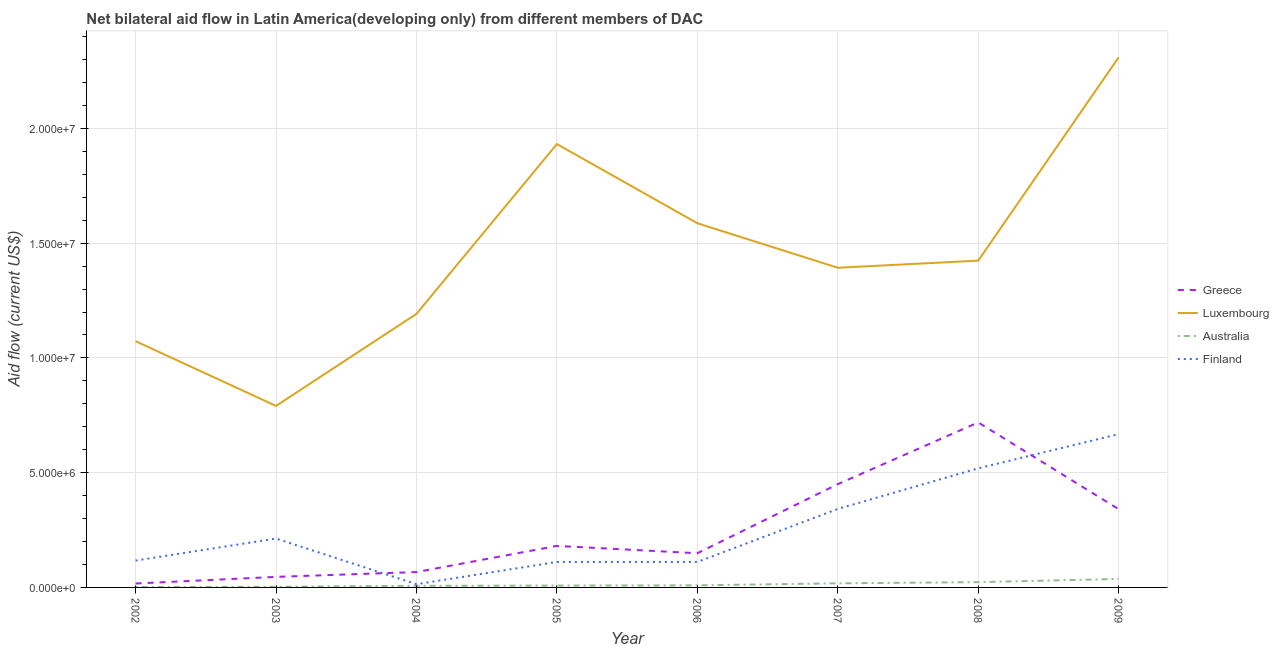How many different coloured lines are there?
Provide a succinct answer. 4. Is the number of lines equal to the number of legend labels?
Offer a terse response. Yes. What is the amount of aid given by australia in 2006?
Your answer should be very brief. 9.00e+04. Across all years, what is the maximum amount of aid given by luxembourg?
Keep it short and to the point. 2.31e+07. Across all years, what is the minimum amount of aid given by australia?
Give a very brief answer. 2.00e+04. What is the total amount of aid given by finland in the graph?
Give a very brief answer. 2.10e+07. What is the difference between the amount of aid given by luxembourg in 2002 and that in 2009?
Make the answer very short. -1.24e+07. What is the difference between the amount of aid given by greece in 2002 and the amount of aid given by finland in 2006?
Ensure brevity in your answer.  -9.40e+05. What is the average amount of aid given by greece per year?
Provide a succinct answer. 2.46e+06. In the year 2003, what is the difference between the amount of aid given by luxembourg and amount of aid given by greece?
Offer a very short reply. 7.45e+06. What is the ratio of the amount of aid given by finland in 2003 to that in 2009?
Keep it short and to the point. 0.32. Is the amount of aid given by finland in 2005 less than that in 2007?
Keep it short and to the point. Yes. Is the difference between the amount of aid given by greece in 2005 and 2007 greater than the difference between the amount of aid given by luxembourg in 2005 and 2007?
Offer a terse response. No. What is the difference between the highest and the second highest amount of aid given by greece?
Provide a succinct answer. 2.69e+06. What is the difference between the highest and the lowest amount of aid given by greece?
Offer a very short reply. 7.02e+06. Is it the case that in every year, the sum of the amount of aid given by greece and amount of aid given by luxembourg is greater than the amount of aid given by australia?
Give a very brief answer. Yes. Is the amount of aid given by australia strictly less than the amount of aid given by luxembourg over the years?
Your answer should be very brief. Yes. What is the difference between two consecutive major ticks on the Y-axis?
Ensure brevity in your answer.  5.00e+06. Does the graph contain grids?
Ensure brevity in your answer.  Yes. Where does the legend appear in the graph?
Your answer should be compact. Center right. What is the title of the graph?
Make the answer very short. Net bilateral aid flow in Latin America(developing only) from different members of DAC. What is the label or title of the X-axis?
Your answer should be compact. Year. What is the Aid flow (current US$) in Luxembourg in 2002?
Your response must be concise. 1.07e+07. What is the Aid flow (current US$) of Australia in 2002?
Offer a terse response. 2.00e+04. What is the Aid flow (current US$) of Finland in 2002?
Your response must be concise. 1.17e+06. What is the Aid flow (current US$) of Luxembourg in 2003?
Give a very brief answer. 7.91e+06. What is the Aid flow (current US$) in Finland in 2003?
Your answer should be very brief. 2.13e+06. What is the Aid flow (current US$) of Greece in 2004?
Your answer should be compact. 6.70e+05. What is the Aid flow (current US$) of Luxembourg in 2004?
Give a very brief answer. 1.19e+07. What is the Aid flow (current US$) in Greece in 2005?
Provide a short and direct response. 1.81e+06. What is the Aid flow (current US$) in Luxembourg in 2005?
Offer a terse response. 1.93e+07. What is the Aid flow (current US$) in Australia in 2005?
Offer a very short reply. 8.00e+04. What is the Aid flow (current US$) in Finland in 2005?
Give a very brief answer. 1.11e+06. What is the Aid flow (current US$) of Greece in 2006?
Offer a very short reply. 1.49e+06. What is the Aid flow (current US$) of Luxembourg in 2006?
Provide a succinct answer. 1.59e+07. What is the Aid flow (current US$) of Finland in 2006?
Ensure brevity in your answer.  1.11e+06. What is the Aid flow (current US$) of Greece in 2007?
Give a very brief answer. 4.50e+06. What is the Aid flow (current US$) of Luxembourg in 2007?
Keep it short and to the point. 1.39e+07. What is the Aid flow (current US$) in Australia in 2007?
Your answer should be very brief. 1.80e+05. What is the Aid flow (current US$) of Finland in 2007?
Your response must be concise. 3.42e+06. What is the Aid flow (current US$) of Greece in 2008?
Provide a succinct answer. 7.19e+06. What is the Aid flow (current US$) of Luxembourg in 2008?
Your response must be concise. 1.42e+07. What is the Aid flow (current US$) of Finland in 2008?
Your answer should be very brief. 5.19e+06. What is the Aid flow (current US$) in Greece in 2009?
Your answer should be compact. 3.41e+06. What is the Aid flow (current US$) of Luxembourg in 2009?
Ensure brevity in your answer.  2.31e+07. What is the Aid flow (current US$) of Finland in 2009?
Offer a very short reply. 6.68e+06. Across all years, what is the maximum Aid flow (current US$) in Greece?
Your answer should be compact. 7.19e+06. Across all years, what is the maximum Aid flow (current US$) in Luxembourg?
Offer a very short reply. 2.31e+07. Across all years, what is the maximum Aid flow (current US$) in Finland?
Your answer should be compact. 6.68e+06. Across all years, what is the minimum Aid flow (current US$) in Luxembourg?
Provide a short and direct response. 7.91e+06. Across all years, what is the minimum Aid flow (current US$) in Australia?
Offer a very short reply. 2.00e+04. What is the total Aid flow (current US$) in Greece in the graph?
Give a very brief answer. 1.97e+07. What is the total Aid flow (current US$) in Luxembourg in the graph?
Offer a very short reply. 1.17e+08. What is the total Aid flow (current US$) in Australia in the graph?
Make the answer very short. 1.07e+06. What is the total Aid flow (current US$) in Finland in the graph?
Your answer should be very brief. 2.10e+07. What is the difference between the Aid flow (current US$) of Luxembourg in 2002 and that in 2003?
Offer a very short reply. 2.82e+06. What is the difference between the Aid flow (current US$) of Finland in 2002 and that in 2003?
Ensure brevity in your answer.  -9.60e+05. What is the difference between the Aid flow (current US$) in Greece in 2002 and that in 2004?
Your answer should be very brief. -5.00e+05. What is the difference between the Aid flow (current US$) in Luxembourg in 2002 and that in 2004?
Offer a very short reply. -1.19e+06. What is the difference between the Aid flow (current US$) in Finland in 2002 and that in 2004?
Your response must be concise. 1.03e+06. What is the difference between the Aid flow (current US$) of Greece in 2002 and that in 2005?
Provide a succinct answer. -1.64e+06. What is the difference between the Aid flow (current US$) of Luxembourg in 2002 and that in 2005?
Ensure brevity in your answer.  -8.59e+06. What is the difference between the Aid flow (current US$) in Australia in 2002 and that in 2005?
Offer a terse response. -6.00e+04. What is the difference between the Aid flow (current US$) of Greece in 2002 and that in 2006?
Your answer should be compact. -1.32e+06. What is the difference between the Aid flow (current US$) in Luxembourg in 2002 and that in 2006?
Make the answer very short. -5.14e+06. What is the difference between the Aid flow (current US$) of Australia in 2002 and that in 2006?
Provide a succinct answer. -7.00e+04. What is the difference between the Aid flow (current US$) in Greece in 2002 and that in 2007?
Keep it short and to the point. -4.33e+06. What is the difference between the Aid flow (current US$) of Luxembourg in 2002 and that in 2007?
Your answer should be very brief. -3.20e+06. What is the difference between the Aid flow (current US$) in Australia in 2002 and that in 2007?
Provide a short and direct response. -1.60e+05. What is the difference between the Aid flow (current US$) of Finland in 2002 and that in 2007?
Offer a very short reply. -2.25e+06. What is the difference between the Aid flow (current US$) of Greece in 2002 and that in 2008?
Offer a terse response. -7.02e+06. What is the difference between the Aid flow (current US$) of Luxembourg in 2002 and that in 2008?
Your answer should be compact. -3.51e+06. What is the difference between the Aid flow (current US$) of Finland in 2002 and that in 2008?
Give a very brief answer. -4.02e+06. What is the difference between the Aid flow (current US$) of Greece in 2002 and that in 2009?
Offer a very short reply. -3.24e+06. What is the difference between the Aid flow (current US$) of Luxembourg in 2002 and that in 2009?
Offer a terse response. -1.24e+07. What is the difference between the Aid flow (current US$) of Australia in 2002 and that in 2009?
Your response must be concise. -3.50e+05. What is the difference between the Aid flow (current US$) in Finland in 2002 and that in 2009?
Your response must be concise. -5.51e+06. What is the difference between the Aid flow (current US$) in Luxembourg in 2003 and that in 2004?
Keep it short and to the point. -4.01e+06. What is the difference between the Aid flow (current US$) of Finland in 2003 and that in 2004?
Give a very brief answer. 1.99e+06. What is the difference between the Aid flow (current US$) in Greece in 2003 and that in 2005?
Give a very brief answer. -1.35e+06. What is the difference between the Aid flow (current US$) in Luxembourg in 2003 and that in 2005?
Your answer should be compact. -1.14e+07. What is the difference between the Aid flow (current US$) in Finland in 2003 and that in 2005?
Make the answer very short. 1.02e+06. What is the difference between the Aid flow (current US$) in Greece in 2003 and that in 2006?
Your answer should be compact. -1.03e+06. What is the difference between the Aid flow (current US$) of Luxembourg in 2003 and that in 2006?
Provide a short and direct response. -7.96e+06. What is the difference between the Aid flow (current US$) of Australia in 2003 and that in 2006?
Ensure brevity in your answer.  -6.00e+04. What is the difference between the Aid flow (current US$) in Finland in 2003 and that in 2006?
Ensure brevity in your answer.  1.02e+06. What is the difference between the Aid flow (current US$) in Greece in 2003 and that in 2007?
Give a very brief answer. -4.04e+06. What is the difference between the Aid flow (current US$) of Luxembourg in 2003 and that in 2007?
Provide a succinct answer. -6.02e+06. What is the difference between the Aid flow (current US$) of Finland in 2003 and that in 2007?
Ensure brevity in your answer.  -1.29e+06. What is the difference between the Aid flow (current US$) in Greece in 2003 and that in 2008?
Your answer should be very brief. -6.73e+06. What is the difference between the Aid flow (current US$) of Luxembourg in 2003 and that in 2008?
Your answer should be very brief. -6.33e+06. What is the difference between the Aid flow (current US$) of Australia in 2003 and that in 2008?
Provide a succinct answer. -2.00e+05. What is the difference between the Aid flow (current US$) in Finland in 2003 and that in 2008?
Ensure brevity in your answer.  -3.06e+06. What is the difference between the Aid flow (current US$) in Greece in 2003 and that in 2009?
Your response must be concise. -2.95e+06. What is the difference between the Aid flow (current US$) in Luxembourg in 2003 and that in 2009?
Your response must be concise. -1.52e+07. What is the difference between the Aid flow (current US$) of Australia in 2003 and that in 2009?
Make the answer very short. -3.40e+05. What is the difference between the Aid flow (current US$) of Finland in 2003 and that in 2009?
Keep it short and to the point. -4.55e+06. What is the difference between the Aid flow (current US$) in Greece in 2004 and that in 2005?
Offer a very short reply. -1.14e+06. What is the difference between the Aid flow (current US$) in Luxembourg in 2004 and that in 2005?
Your response must be concise. -7.40e+06. What is the difference between the Aid flow (current US$) in Australia in 2004 and that in 2005?
Ensure brevity in your answer.  -10000. What is the difference between the Aid flow (current US$) of Finland in 2004 and that in 2005?
Make the answer very short. -9.70e+05. What is the difference between the Aid flow (current US$) of Greece in 2004 and that in 2006?
Provide a succinct answer. -8.20e+05. What is the difference between the Aid flow (current US$) of Luxembourg in 2004 and that in 2006?
Keep it short and to the point. -3.95e+06. What is the difference between the Aid flow (current US$) in Finland in 2004 and that in 2006?
Give a very brief answer. -9.70e+05. What is the difference between the Aid flow (current US$) of Greece in 2004 and that in 2007?
Your answer should be very brief. -3.83e+06. What is the difference between the Aid flow (current US$) of Luxembourg in 2004 and that in 2007?
Provide a short and direct response. -2.01e+06. What is the difference between the Aid flow (current US$) of Finland in 2004 and that in 2007?
Ensure brevity in your answer.  -3.28e+06. What is the difference between the Aid flow (current US$) of Greece in 2004 and that in 2008?
Offer a terse response. -6.52e+06. What is the difference between the Aid flow (current US$) in Luxembourg in 2004 and that in 2008?
Your response must be concise. -2.32e+06. What is the difference between the Aid flow (current US$) in Finland in 2004 and that in 2008?
Offer a very short reply. -5.05e+06. What is the difference between the Aid flow (current US$) of Greece in 2004 and that in 2009?
Make the answer very short. -2.74e+06. What is the difference between the Aid flow (current US$) of Luxembourg in 2004 and that in 2009?
Ensure brevity in your answer.  -1.12e+07. What is the difference between the Aid flow (current US$) in Finland in 2004 and that in 2009?
Your answer should be compact. -6.54e+06. What is the difference between the Aid flow (current US$) in Greece in 2005 and that in 2006?
Give a very brief answer. 3.20e+05. What is the difference between the Aid flow (current US$) in Luxembourg in 2005 and that in 2006?
Give a very brief answer. 3.45e+06. What is the difference between the Aid flow (current US$) of Australia in 2005 and that in 2006?
Your answer should be very brief. -10000. What is the difference between the Aid flow (current US$) of Greece in 2005 and that in 2007?
Give a very brief answer. -2.69e+06. What is the difference between the Aid flow (current US$) of Luxembourg in 2005 and that in 2007?
Provide a short and direct response. 5.39e+06. What is the difference between the Aid flow (current US$) of Australia in 2005 and that in 2007?
Offer a very short reply. -1.00e+05. What is the difference between the Aid flow (current US$) of Finland in 2005 and that in 2007?
Give a very brief answer. -2.31e+06. What is the difference between the Aid flow (current US$) in Greece in 2005 and that in 2008?
Your response must be concise. -5.38e+06. What is the difference between the Aid flow (current US$) in Luxembourg in 2005 and that in 2008?
Your answer should be very brief. 5.08e+06. What is the difference between the Aid flow (current US$) in Australia in 2005 and that in 2008?
Your answer should be compact. -1.50e+05. What is the difference between the Aid flow (current US$) of Finland in 2005 and that in 2008?
Keep it short and to the point. -4.08e+06. What is the difference between the Aid flow (current US$) in Greece in 2005 and that in 2009?
Your response must be concise. -1.60e+06. What is the difference between the Aid flow (current US$) in Luxembourg in 2005 and that in 2009?
Your answer should be very brief. -3.78e+06. What is the difference between the Aid flow (current US$) of Finland in 2005 and that in 2009?
Provide a succinct answer. -5.57e+06. What is the difference between the Aid flow (current US$) in Greece in 2006 and that in 2007?
Make the answer very short. -3.01e+06. What is the difference between the Aid flow (current US$) in Luxembourg in 2006 and that in 2007?
Give a very brief answer. 1.94e+06. What is the difference between the Aid flow (current US$) of Finland in 2006 and that in 2007?
Your response must be concise. -2.31e+06. What is the difference between the Aid flow (current US$) of Greece in 2006 and that in 2008?
Keep it short and to the point. -5.70e+06. What is the difference between the Aid flow (current US$) of Luxembourg in 2006 and that in 2008?
Give a very brief answer. 1.63e+06. What is the difference between the Aid flow (current US$) in Finland in 2006 and that in 2008?
Make the answer very short. -4.08e+06. What is the difference between the Aid flow (current US$) in Greece in 2006 and that in 2009?
Your response must be concise. -1.92e+06. What is the difference between the Aid flow (current US$) in Luxembourg in 2006 and that in 2009?
Make the answer very short. -7.23e+06. What is the difference between the Aid flow (current US$) in Australia in 2006 and that in 2009?
Your answer should be very brief. -2.80e+05. What is the difference between the Aid flow (current US$) of Finland in 2006 and that in 2009?
Your response must be concise. -5.57e+06. What is the difference between the Aid flow (current US$) of Greece in 2007 and that in 2008?
Provide a succinct answer. -2.69e+06. What is the difference between the Aid flow (current US$) in Luxembourg in 2007 and that in 2008?
Keep it short and to the point. -3.10e+05. What is the difference between the Aid flow (current US$) of Australia in 2007 and that in 2008?
Ensure brevity in your answer.  -5.00e+04. What is the difference between the Aid flow (current US$) of Finland in 2007 and that in 2008?
Offer a very short reply. -1.77e+06. What is the difference between the Aid flow (current US$) of Greece in 2007 and that in 2009?
Provide a short and direct response. 1.09e+06. What is the difference between the Aid flow (current US$) in Luxembourg in 2007 and that in 2009?
Your answer should be compact. -9.17e+06. What is the difference between the Aid flow (current US$) in Finland in 2007 and that in 2009?
Make the answer very short. -3.26e+06. What is the difference between the Aid flow (current US$) of Greece in 2008 and that in 2009?
Your answer should be compact. 3.78e+06. What is the difference between the Aid flow (current US$) of Luxembourg in 2008 and that in 2009?
Your answer should be very brief. -8.86e+06. What is the difference between the Aid flow (current US$) of Australia in 2008 and that in 2009?
Provide a short and direct response. -1.40e+05. What is the difference between the Aid flow (current US$) in Finland in 2008 and that in 2009?
Your answer should be compact. -1.49e+06. What is the difference between the Aid flow (current US$) of Greece in 2002 and the Aid flow (current US$) of Luxembourg in 2003?
Ensure brevity in your answer.  -7.74e+06. What is the difference between the Aid flow (current US$) in Greece in 2002 and the Aid flow (current US$) in Finland in 2003?
Keep it short and to the point. -1.96e+06. What is the difference between the Aid flow (current US$) of Luxembourg in 2002 and the Aid flow (current US$) of Australia in 2003?
Keep it short and to the point. 1.07e+07. What is the difference between the Aid flow (current US$) in Luxembourg in 2002 and the Aid flow (current US$) in Finland in 2003?
Make the answer very short. 8.60e+06. What is the difference between the Aid flow (current US$) of Australia in 2002 and the Aid flow (current US$) of Finland in 2003?
Your response must be concise. -2.11e+06. What is the difference between the Aid flow (current US$) of Greece in 2002 and the Aid flow (current US$) of Luxembourg in 2004?
Offer a very short reply. -1.18e+07. What is the difference between the Aid flow (current US$) of Luxembourg in 2002 and the Aid flow (current US$) of Australia in 2004?
Give a very brief answer. 1.07e+07. What is the difference between the Aid flow (current US$) in Luxembourg in 2002 and the Aid flow (current US$) in Finland in 2004?
Ensure brevity in your answer.  1.06e+07. What is the difference between the Aid flow (current US$) in Australia in 2002 and the Aid flow (current US$) in Finland in 2004?
Provide a succinct answer. -1.20e+05. What is the difference between the Aid flow (current US$) in Greece in 2002 and the Aid flow (current US$) in Luxembourg in 2005?
Offer a very short reply. -1.92e+07. What is the difference between the Aid flow (current US$) of Greece in 2002 and the Aid flow (current US$) of Finland in 2005?
Provide a succinct answer. -9.40e+05. What is the difference between the Aid flow (current US$) of Luxembourg in 2002 and the Aid flow (current US$) of Australia in 2005?
Make the answer very short. 1.06e+07. What is the difference between the Aid flow (current US$) of Luxembourg in 2002 and the Aid flow (current US$) of Finland in 2005?
Offer a very short reply. 9.62e+06. What is the difference between the Aid flow (current US$) in Australia in 2002 and the Aid flow (current US$) in Finland in 2005?
Provide a succinct answer. -1.09e+06. What is the difference between the Aid flow (current US$) of Greece in 2002 and the Aid flow (current US$) of Luxembourg in 2006?
Keep it short and to the point. -1.57e+07. What is the difference between the Aid flow (current US$) in Greece in 2002 and the Aid flow (current US$) in Australia in 2006?
Your answer should be very brief. 8.00e+04. What is the difference between the Aid flow (current US$) in Greece in 2002 and the Aid flow (current US$) in Finland in 2006?
Your answer should be compact. -9.40e+05. What is the difference between the Aid flow (current US$) in Luxembourg in 2002 and the Aid flow (current US$) in Australia in 2006?
Provide a succinct answer. 1.06e+07. What is the difference between the Aid flow (current US$) of Luxembourg in 2002 and the Aid flow (current US$) of Finland in 2006?
Offer a very short reply. 9.62e+06. What is the difference between the Aid flow (current US$) of Australia in 2002 and the Aid flow (current US$) of Finland in 2006?
Provide a succinct answer. -1.09e+06. What is the difference between the Aid flow (current US$) in Greece in 2002 and the Aid flow (current US$) in Luxembourg in 2007?
Make the answer very short. -1.38e+07. What is the difference between the Aid flow (current US$) of Greece in 2002 and the Aid flow (current US$) of Australia in 2007?
Keep it short and to the point. -10000. What is the difference between the Aid flow (current US$) in Greece in 2002 and the Aid flow (current US$) in Finland in 2007?
Give a very brief answer. -3.25e+06. What is the difference between the Aid flow (current US$) in Luxembourg in 2002 and the Aid flow (current US$) in Australia in 2007?
Provide a short and direct response. 1.06e+07. What is the difference between the Aid flow (current US$) in Luxembourg in 2002 and the Aid flow (current US$) in Finland in 2007?
Ensure brevity in your answer.  7.31e+06. What is the difference between the Aid flow (current US$) of Australia in 2002 and the Aid flow (current US$) of Finland in 2007?
Make the answer very short. -3.40e+06. What is the difference between the Aid flow (current US$) of Greece in 2002 and the Aid flow (current US$) of Luxembourg in 2008?
Your answer should be compact. -1.41e+07. What is the difference between the Aid flow (current US$) of Greece in 2002 and the Aid flow (current US$) of Australia in 2008?
Make the answer very short. -6.00e+04. What is the difference between the Aid flow (current US$) in Greece in 2002 and the Aid flow (current US$) in Finland in 2008?
Your response must be concise. -5.02e+06. What is the difference between the Aid flow (current US$) in Luxembourg in 2002 and the Aid flow (current US$) in Australia in 2008?
Your response must be concise. 1.05e+07. What is the difference between the Aid flow (current US$) of Luxembourg in 2002 and the Aid flow (current US$) of Finland in 2008?
Provide a succinct answer. 5.54e+06. What is the difference between the Aid flow (current US$) in Australia in 2002 and the Aid flow (current US$) in Finland in 2008?
Ensure brevity in your answer.  -5.17e+06. What is the difference between the Aid flow (current US$) in Greece in 2002 and the Aid flow (current US$) in Luxembourg in 2009?
Provide a short and direct response. -2.29e+07. What is the difference between the Aid flow (current US$) in Greece in 2002 and the Aid flow (current US$) in Finland in 2009?
Your answer should be compact. -6.51e+06. What is the difference between the Aid flow (current US$) in Luxembourg in 2002 and the Aid flow (current US$) in Australia in 2009?
Give a very brief answer. 1.04e+07. What is the difference between the Aid flow (current US$) in Luxembourg in 2002 and the Aid flow (current US$) in Finland in 2009?
Give a very brief answer. 4.05e+06. What is the difference between the Aid flow (current US$) of Australia in 2002 and the Aid flow (current US$) of Finland in 2009?
Your answer should be very brief. -6.66e+06. What is the difference between the Aid flow (current US$) in Greece in 2003 and the Aid flow (current US$) in Luxembourg in 2004?
Your response must be concise. -1.15e+07. What is the difference between the Aid flow (current US$) of Greece in 2003 and the Aid flow (current US$) of Finland in 2004?
Ensure brevity in your answer.  3.20e+05. What is the difference between the Aid flow (current US$) in Luxembourg in 2003 and the Aid flow (current US$) in Australia in 2004?
Provide a succinct answer. 7.84e+06. What is the difference between the Aid flow (current US$) of Luxembourg in 2003 and the Aid flow (current US$) of Finland in 2004?
Your answer should be compact. 7.77e+06. What is the difference between the Aid flow (current US$) of Greece in 2003 and the Aid flow (current US$) of Luxembourg in 2005?
Your answer should be very brief. -1.89e+07. What is the difference between the Aid flow (current US$) of Greece in 2003 and the Aid flow (current US$) of Australia in 2005?
Offer a terse response. 3.80e+05. What is the difference between the Aid flow (current US$) in Greece in 2003 and the Aid flow (current US$) in Finland in 2005?
Keep it short and to the point. -6.50e+05. What is the difference between the Aid flow (current US$) of Luxembourg in 2003 and the Aid flow (current US$) of Australia in 2005?
Give a very brief answer. 7.83e+06. What is the difference between the Aid flow (current US$) of Luxembourg in 2003 and the Aid flow (current US$) of Finland in 2005?
Give a very brief answer. 6.80e+06. What is the difference between the Aid flow (current US$) of Australia in 2003 and the Aid flow (current US$) of Finland in 2005?
Keep it short and to the point. -1.08e+06. What is the difference between the Aid flow (current US$) of Greece in 2003 and the Aid flow (current US$) of Luxembourg in 2006?
Provide a short and direct response. -1.54e+07. What is the difference between the Aid flow (current US$) of Greece in 2003 and the Aid flow (current US$) of Finland in 2006?
Ensure brevity in your answer.  -6.50e+05. What is the difference between the Aid flow (current US$) of Luxembourg in 2003 and the Aid flow (current US$) of Australia in 2006?
Offer a very short reply. 7.82e+06. What is the difference between the Aid flow (current US$) of Luxembourg in 2003 and the Aid flow (current US$) of Finland in 2006?
Offer a terse response. 6.80e+06. What is the difference between the Aid flow (current US$) in Australia in 2003 and the Aid flow (current US$) in Finland in 2006?
Your response must be concise. -1.08e+06. What is the difference between the Aid flow (current US$) in Greece in 2003 and the Aid flow (current US$) in Luxembourg in 2007?
Your answer should be compact. -1.35e+07. What is the difference between the Aid flow (current US$) of Greece in 2003 and the Aid flow (current US$) of Finland in 2007?
Keep it short and to the point. -2.96e+06. What is the difference between the Aid flow (current US$) in Luxembourg in 2003 and the Aid flow (current US$) in Australia in 2007?
Provide a short and direct response. 7.73e+06. What is the difference between the Aid flow (current US$) of Luxembourg in 2003 and the Aid flow (current US$) of Finland in 2007?
Offer a very short reply. 4.49e+06. What is the difference between the Aid flow (current US$) of Australia in 2003 and the Aid flow (current US$) of Finland in 2007?
Offer a terse response. -3.39e+06. What is the difference between the Aid flow (current US$) in Greece in 2003 and the Aid flow (current US$) in Luxembourg in 2008?
Make the answer very short. -1.38e+07. What is the difference between the Aid flow (current US$) in Greece in 2003 and the Aid flow (current US$) in Australia in 2008?
Ensure brevity in your answer.  2.30e+05. What is the difference between the Aid flow (current US$) in Greece in 2003 and the Aid flow (current US$) in Finland in 2008?
Make the answer very short. -4.73e+06. What is the difference between the Aid flow (current US$) in Luxembourg in 2003 and the Aid flow (current US$) in Australia in 2008?
Make the answer very short. 7.68e+06. What is the difference between the Aid flow (current US$) in Luxembourg in 2003 and the Aid flow (current US$) in Finland in 2008?
Your answer should be very brief. 2.72e+06. What is the difference between the Aid flow (current US$) in Australia in 2003 and the Aid flow (current US$) in Finland in 2008?
Provide a succinct answer. -5.16e+06. What is the difference between the Aid flow (current US$) of Greece in 2003 and the Aid flow (current US$) of Luxembourg in 2009?
Provide a short and direct response. -2.26e+07. What is the difference between the Aid flow (current US$) of Greece in 2003 and the Aid flow (current US$) of Australia in 2009?
Your answer should be very brief. 9.00e+04. What is the difference between the Aid flow (current US$) of Greece in 2003 and the Aid flow (current US$) of Finland in 2009?
Keep it short and to the point. -6.22e+06. What is the difference between the Aid flow (current US$) in Luxembourg in 2003 and the Aid flow (current US$) in Australia in 2009?
Ensure brevity in your answer.  7.54e+06. What is the difference between the Aid flow (current US$) in Luxembourg in 2003 and the Aid flow (current US$) in Finland in 2009?
Your answer should be very brief. 1.23e+06. What is the difference between the Aid flow (current US$) in Australia in 2003 and the Aid flow (current US$) in Finland in 2009?
Keep it short and to the point. -6.65e+06. What is the difference between the Aid flow (current US$) in Greece in 2004 and the Aid flow (current US$) in Luxembourg in 2005?
Provide a succinct answer. -1.86e+07. What is the difference between the Aid flow (current US$) of Greece in 2004 and the Aid flow (current US$) of Australia in 2005?
Offer a terse response. 5.90e+05. What is the difference between the Aid flow (current US$) of Greece in 2004 and the Aid flow (current US$) of Finland in 2005?
Ensure brevity in your answer.  -4.40e+05. What is the difference between the Aid flow (current US$) of Luxembourg in 2004 and the Aid flow (current US$) of Australia in 2005?
Your answer should be very brief. 1.18e+07. What is the difference between the Aid flow (current US$) of Luxembourg in 2004 and the Aid flow (current US$) of Finland in 2005?
Keep it short and to the point. 1.08e+07. What is the difference between the Aid flow (current US$) of Australia in 2004 and the Aid flow (current US$) of Finland in 2005?
Your answer should be very brief. -1.04e+06. What is the difference between the Aid flow (current US$) of Greece in 2004 and the Aid flow (current US$) of Luxembourg in 2006?
Provide a succinct answer. -1.52e+07. What is the difference between the Aid flow (current US$) in Greece in 2004 and the Aid flow (current US$) in Australia in 2006?
Ensure brevity in your answer.  5.80e+05. What is the difference between the Aid flow (current US$) in Greece in 2004 and the Aid flow (current US$) in Finland in 2006?
Make the answer very short. -4.40e+05. What is the difference between the Aid flow (current US$) in Luxembourg in 2004 and the Aid flow (current US$) in Australia in 2006?
Ensure brevity in your answer.  1.18e+07. What is the difference between the Aid flow (current US$) of Luxembourg in 2004 and the Aid flow (current US$) of Finland in 2006?
Your answer should be very brief. 1.08e+07. What is the difference between the Aid flow (current US$) in Australia in 2004 and the Aid flow (current US$) in Finland in 2006?
Your answer should be compact. -1.04e+06. What is the difference between the Aid flow (current US$) in Greece in 2004 and the Aid flow (current US$) in Luxembourg in 2007?
Your response must be concise. -1.33e+07. What is the difference between the Aid flow (current US$) in Greece in 2004 and the Aid flow (current US$) in Australia in 2007?
Keep it short and to the point. 4.90e+05. What is the difference between the Aid flow (current US$) in Greece in 2004 and the Aid flow (current US$) in Finland in 2007?
Provide a short and direct response. -2.75e+06. What is the difference between the Aid flow (current US$) in Luxembourg in 2004 and the Aid flow (current US$) in Australia in 2007?
Your answer should be very brief. 1.17e+07. What is the difference between the Aid flow (current US$) of Luxembourg in 2004 and the Aid flow (current US$) of Finland in 2007?
Your answer should be very brief. 8.50e+06. What is the difference between the Aid flow (current US$) of Australia in 2004 and the Aid flow (current US$) of Finland in 2007?
Offer a very short reply. -3.35e+06. What is the difference between the Aid flow (current US$) in Greece in 2004 and the Aid flow (current US$) in Luxembourg in 2008?
Offer a very short reply. -1.36e+07. What is the difference between the Aid flow (current US$) in Greece in 2004 and the Aid flow (current US$) in Australia in 2008?
Offer a very short reply. 4.40e+05. What is the difference between the Aid flow (current US$) of Greece in 2004 and the Aid flow (current US$) of Finland in 2008?
Give a very brief answer. -4.52e+06. What is the difference between the Aid flow (current US$) of Luxembourg in 2004 and the Aid flow (current US$) of Australia in 2008?
Make the answer very short. 1.17e+07. What is the difference between the Aid flow (current US$) of Luxembourg in 2004 and the Aid flow (current US$) of Finland in 2008?
Make the answer very short. 6.73e+06. What is the difference between the Aid flow (current US$) of Australia in 2004 and the Aid flow (current US$) of Finland in 2008?
Keep it short and to the point. -5.12e+06. What is the difference between the Aid flow (current US$) in Greece in 2004 and the Aid flow (current US$) in Luxembourg in 2009?
Ensure brevity in your answer.  -2.24e+07. What is the difference between the Aid flow (current US$) in Greece in 2004 and the Aid flow (current US$) in Finland in 2009?
Offer a terse response. -6.01e+06. What is the difference between the Aid flow (current US$) of Luxembourg in 2004 and the Aid flow (current US$) of Australia in 2009?
Ensure brevity in your answer.  1.16e+07. What is the difference between the Aid flow (current US$) of Luxembourg in 2004 and the Aid flow (current US$) of Finland in 2009?
Give a very brief answer. 5.24e+06. What is the difference between the Aid flow (current US$) of Australia in 2004 and the Aid flow (current US$) of Finland in 2009?
Give a very brief answer. -6.61e+06. What is the difference between the Aid flow (current US$) of Greece in 2005 and the Aid flow (current US$) of Luxembourg in 2006?
Give a very brief answer. -1.41e+07. What is the difference between the Aid flow (current US$) of Greece in 2005 and the Aid flow (current US$) of Australia in 2006?
Provide a succinct answer. 1.72e+06. What is the difference between the Aid flow (current US$) in Greece in 2005 and the Aid flow (current US$) in Finland in 2006?
Give a very brief answer. 7.00e+05. What is the difference between the Aid flow (current US$) of Luxembourg in 2005 and the Aid flow (current US$) of Australia in 2006?
Your answer should be compact. 1.92e+07. What is the difference between the Aid flow (current US$) in Luxembourg in 2005 and the Aid flow (current US$) in Finland in 2006?
Make the answer very short. 1.82e+07. What is the difference between the Aid flow (current US$) in Australia in 2005 and the Aid flow (current US$) in Finland in 2006?
Provide a succinct answer. -1.03e+06. What is the difference between the Aid flow (current US$) in Greece in 2005 and the Aid flow (current US$) in Luxembourg in 2007?
Ensure brevity in your answer.  -1.21e+07. What is the difference between the Aid flow (current US$) of Greece in 2005 and the Aid flow (current US$) of Australia in 2007?
Ensure brevity in your answer.  1.63e+06. What is the difference between the Aid flow (current US$) in Greece in 2005 and the Aid flow (current US$) in Finland in 2007?
Provide a succinct answer. -1.61e+06. What is the difference between the Aid flow (current US$) in Luxembourg in 2005 and the Aid flow (current US$) in Australia in 2007?
Provide a succinct answer. 1.91e+07. What is the difference between the Aid flow (current US$) of Luxembourg in 2005 and the Aid flow (current US$) of Finland in 2007?
Provide a succinct answer. 1.59e+07. What is the difference between the Aid flow (current US$) of Australia in 2005 and the Aid flow (current US$) of Finland in 2007?
Provide a succinct answer. -3.34e+06. What is the difference between the Aid flow (current US$) of Greece in 2005 and the Aid flow (current US$) of Luxembourg in 2008?
Keep it short and to the point. -1.24e+07. What is the difference between the Aid flow (current US$) in Greece in 2005 and the Aid flow (current US$) in Australia in 2008?
Your response must be concise. 1.58e+06. What is the difference between the Aid flow (current US$) in Greece in 2005 and the Aid flow (current US$) in Finland in 2008?
Give a very brief answer. -3.38e+06. What is the difference between the Aid flow (current US$) in Luxembourg in 2005 and the Aid flow (current US$) in Australia in 2008?
Keep it short and to the point. 1.91e+07. What is the difference between the Aid flow (current US$) in Luxembourg in 2005 and the Aid flow (current US$) in Finland in 2008?
Provide a succinct answer. 1.41e+07. What is the difference between the Aid flow (current US$) in Australia in 2005 and the Aid flow (current US$) in Finland in 2008?
Your response must be concise. -5.11e+06. What is the difference between the Aid flow (current US$) of Greece in 2005 and the Aid flow (current US$) of Luxembourg in 2009?
Give a very brief answer. -2.13e+07. What is the difference between the Aid flow (current US$) of Greece in 2005 and the Aid flow (current US$) of Australia in 2009?
Your response must be concise. 1.44e+06. What is the difference between the Aid flow (current US$) of Greece in 2005 and the Aid flow (current US$) of Finland in 2009?
Keep it short and to the point. -4.87e+06. What is the difference between the Aid flow (current US$) in Luxembourg in 2005 and the Aid flow (current US$) in Australia in 2009?
Give a very brief answer. 1.90e+07. What is the difference between the Aid flow (current US$) in Luxembourg in 2005 and the Aid flow (current US$) in Finland in 2009?
Provide a short and direct response. 1.26e+07. What is the difference between the Aid flow (current US$) in Australia in 2005 and the Aid flow (current US$) in Finland in 2009?
Offer a terse response. -6.60e+06. What is the difference between the Aid flow (current US$) in Greece in 2006 and the Aid flow (current US$) in Luxembourg in 2007?
Give a very brief answer. -1.24e+07. What is the difference between the Aid flow (current US$) of Greece in 2006 and the Aid flow (current US$) of Australia in 2007?
Give a very brief answer. 1.31e+06. What is the difference between the Aid flow (current US$) of Greece in 2006 and the Aid flow (current US$) of Finland in 2007?
Your answer should be very brief. -1.93e+06. What is the difference between the Aid flow (current US$) in Luxembourg in 2006 and the Aid flow (current US$) in Australia in 2007?
Provide a short and direct response. 1.57e+07. What is the difference between the Aid flow (current US$) of Luxembourg in 2006 and the Aid flow (current US$) of Finland in 2007?
Offer a terse response. 1.24e+07. What is the difference between the Aid flow (current US$) of Australia in 2006 and the Aid flow (current US$) of Finland in 2007?
Your answer should be very brief. -3.33e+06. What is the difference between the Aid flow (current US$) in Greece in 2006 and the Aid flow (current US$) in Luxembourg in 2008?
Provide a succinct answer. -1.28e+07. What is the difference between the Aid flow (current US$) in Greece in 2006 and the Aid flow (current US$) in Australia in 2008?
Your response must be concise. 1.26e+06. What is the difference between the Aid flow (current US$) in Greece in 2006 and the Aid flow (current US$) in Finland in 2008?
Ensure brevity in your answer.  -3.70e+06. What is the difference between the Aid flow (current US$) of Luxembourg in 2006 and the Aid flow (current US$) of Australia in 2008?
Your answer should be compact. 1.56e+07. What is the difference between the Aid flow (current US$) in Luxembourg in 2006 and the Aid flow (current US$) in Finland in 2008?
Provide a short and direct response. 1.07e+07. What is the difference between the Aid flow (current US$) in Australia in 2006 and the Aid flow (current US$) in Finland in 2008?
Your response must be concise. -5.10e+06. What is the difference between the Aid flow (current US$) of Greece in 2006 and the Aid flow (current US$) of Luxembourg in 2009?
Offer a very short reply. -2.16e+07. What is the difference between the Aid flow (current US$) in Greece in 2006 and the Aid flow (current US$) in Australia in 2009?
Provide a short and direct response. 1.12e+06. What is the difference between the Aid flow (current US$) of Greece in 2006 and the Aid flow (current US$) of Finland in 2009?
Ensure brevity in your answer.  -5.19e+06. What is the difference between the Aid flow (current US$) in Luxembourg in 2006 and the Aid flow (current US$) in Australia in 2009?
Offer a very short reply. 1.55e+07. What is the difference between the Aid flow (current US$) of Luxembourg in 2006 and the Aid flow (current US$) of Finland in 2009?
Ensure brevity in your answer.  9.19e+06. What is the difference between the Aid flow (current US$) in Australia in 2006 and the Aid flow (current US$) in Finland in 2009?
Offer a terse response. -6.59e+06. What is the difference between the Aid flow (current US$) of Greece in 2007 and the Aid flow (current US$) of Luxembourg in 2008?
Give a very brief answer. -9.74e+06. What is the difference between the Aid flow (current US$) in Greece in 2007 and the Aid flow (current US$) in Australia in 2008?
Offer a terse response. 4.27e+06. What is the difference between the Aid flow (current US$) of Greece in 2007 and the Aid flow (current US$) of Finland in 2008?
Your response must be concise. -6.90e+05. What is the difference between the Aid flow (current US$) of Luxembourg in 2007 and the Aid flow (current US$) of Australia in 2008?
Give a very brief answer. 1.37e+07. What is the difference between the Aid flow (current US$) in Luxembourg in 2007 and the Aid flow (current US$) in Finland in 2008?
Keep it short and to the point. 8.74e+06. What is the difference between the Aid flow (current US$) of Australia in 2007 and the Aid flow (current US$) of Finland in 2008?
Your response must be concise. -5.01e+06. What is the difference between the Aid flow (current US$) of Greece in 2007 and the Aid flow (current US$) of Luxembourg in 2009?
Offer a very short reply. -1.86e+07. What is the difference between the Aid flow (current US$) of Greece in 2007 and the Aid flow (current US$) of Australia in 2009?
Your response must be concise. 4.13e+06. What is the difference between the Aid flow (current US$) in Greece in 2007 and the Aid flow (current US$) in Finland in 2009?
Give a very brief answer. -2.18e+06. What is the difference between the Aid flow (current US$) of Luxembourg in 2007 and the Aid flow (current US$) of Australia in 2009?
Keep it short and to the point. 1.36e+07. What is the difference between the Aid flow (current US$) in Luxembourg in 2007 and the Aid flow (current US$) in Finland in 2009?
Your answer should be compact. 7.25e+06. What is the difference between the Aid flow (current US$) of Australia in 2007 and the Aid flow (current US$) of Finland in 2009?
Offer a terse response. -6.50e+06. What is the difference between the Aid flow (current US$) in Greece in 2008 and the Aid flow (current US$) in Luxembourg in 2009?
Provide a succinct answer. -1.59e+07. What is the difference between the Aid flow (current US$) in Greece in 2008 and the Aid flow (current US$) in Australia in 2009?
Offer a terse response. 6.82e+06. What is the difference between the Aid flow (current US$) of Greece in 2008 and the Aid flow (current US$) of Finland in 2009?
Offer a very short reply. 5.10e+05. What is the difference between the Aid flow (current US$) of Luxembourg in 2008 and the Aid flow (current US$) of Australia in 2009?
Give a very brief answer. 1.39e+07. What is the difference between the Aid flow (current US$) of Luxembourg in 2008 and the Aid flow (current US$) of Finland in 2009?
Offer a terse response. 7.56e+06. What is the difference between the Aid flow (current US$) of Australia in 2008 and the Aid flow (current US$) of Finland in 2009?
Keep it short and to the point. -6.45e+06. What is the average Aid flow (current US$) in Greece per year?
Your answer should be very brief. 2.46e+06. What is the average Aid flow (current US$) in Luxembourg per year?
Provide a short and direct response. 1.46e+07. What is the average Aid flow (current US$) of Australia per year?
Give a very brief answer. 1.34e+05. What is the average Aid flow (current US$) in Finland per year?
Your answer should be compact. 2.62e+06. In the year 2002, what is the difference between the Aid flow (current US$) of Greece and Aid flow (current US$) of Luxembourg?
Keep it short and to the point. -1.06e+07. In the year 2002, what is the difference between the Aid flow (current US$) of Greece and Aid flow (current US$) of Australia?
Give a very brief answer. 1.50e+05. In the year 2002, what is the difference between the Aid flow (current US$) in Greece and Aid flow (current US$) in Finland?
Make the answer very short. -1.00e+06. In the year 2002, what is the difference between the Aid flow (current US$) of Luxembourg and Aid flow (current US$) of Australia?
Provide a succinct answer. 1.07e+07. In the year 2002, what is the difference between the Aid flow (current US$) of Luxembourg and Aid flow (current US$) of Finland?
Keep it short and to the point. 9.56e+06. In the year 2002, what is the difference between the Aid flow (current US$) in Australia and Aid flow (current US$) in Finland?
Provide a short and direct response. -1.15e+06. In the year 2003, what is the difference between the Aid flow (current US$) in Greece and Aid flow (current US$) in Luxembourg?
Offer a very short reply. -7.45e+06. In the year 2003, what is the difference between the Aid flow (current US$) in Greece and Aid flow (current US$) in Australia?
Offer a very short reply. 4.30e+05. In the year 2003, what is the difference between the Aid flow (current US$) of Greece and Aid flow (current US$) of Finland?
Your answer should be compact. -1.67e+06. In the year 2003, what is the difference between the Aid flow (current US$) in Luxembourg and Aid flow (current US$) in Australia?
Ensure brevity in your answer.  7.88e+06. In the year 2003, what is the difference between the Aid flow (current US$) of Luxembourg and Aid flow (current US$) of Finland?
Your response must be concise. 5.78e+06. In the year 2003, what is the difference between the Aid flow (current US$) in Australia and Aid flow (current US$) in Finland?
Give a very brief answer. -2.10e+06. In the year 2004, what is the difference between the Aid flow (current US$) in Greece and Aid flow (current US$) in Luxembourg?
Give a very brief answer. -1.12e+07. In the year 2004, what is the difference between the Aid flow (current US$) in Greece and Aid flow (current US$) in Finland?
Provide a succinct answer. 5.30e+05. In the year 2004, what is the difference between the Aid flow (current US$) in Luxembourg and Aid flow (current US$) in Australia?
Your response must be concise. 1.18e+07. In the year 2004, what is the difference between the Aid flow (current US$) in Luxembourg and Aid flow (current US$) in Finland?
Your response must be concise. 1.18e+07. In the year 2005, what is the difference between the Aid flow (current US$) in Greece and Aid flow (current US$) in Luxembourg?
Your response must be concise. -1.75e+07. In the year 2005, what is the difference between the Aid flow (current US$) of Greece and Aid flow (current US$) of Australia?
Ensure brevity in your answer.  1.73e+06. In the year 2005, what is the difference between the Aid flow (current US$) in Luxembourg and Aid flow (current US$) in Australia?
Provide a succinct answer. 1.92e+07. In the year 2005, what is the difference between the Aid flow (current US$) of Luxembourg and Aid flow (current US$) of Finland?
Offer a very short reply. 1.82e+07. In the year 2005, what is the difference between the Aid flow (current US$) of Australia and Aid flow (current US$) of Finland?
Provide a succinct answer. -1.03e+06. In the year 2006, what is the difference between the Aid flow (current US$) of Greece and Aid flow (current US$) of Luxembourg?
Your answer should be compact. -1.44e+07. In the year 2006, what is the difference between the Aid flow (current US$) in Greece and Aid flow (current US$) in Australia?
Make the answer very short. 1.40e+06. In the year 2006, what is the difference between the Aid flow (current US$) of Greece and Aid flow (current US$) of Finland?
Ensure brevity in your answer.  3.80e+05. In the year 2006, what is the difference between the Aid flow (current US$) of Luxembourg and Aid flow (current US$) of Australia?
Provide a succinct answer. 1.58e+07. In the year 2006, what is the difference between the Aid flow (current US$) of Luxembourg and Aid flow (current US$) of Finland?
Provide a succinct answer. 1.48e+07. In the year 2006, what is the difference between the Aid flow (current US$) in Australia and Aid flow (current US$) in Finland?
Your response must be concise. -1.02e+06. In the year 2007, what is the difference between the Aid flow (current US$) in Greece and Aid flow (current US$) in Luxembourg?
Make the answer very short. -9.43e+06. In the year 2007, what is the difference between the Aid flow (current US$) in Greece and Aid flow (current US$) in Australia?
Offer a very short reply. 4.32e+06. In the year 2007, what is the difference between the Aid flow (current US$) of Greece and Aid flow (current US$) of Finland?
Offer a very short reply. 1.08e+06. In the year 2007, what is the difference between the Aid flow (current US$) of Luxembourg and Aid flow (current US$) of Australia?
Offer a very short reply. 1.38e+07. In the year 2007, what is the difference between the Aid flow (current US$) of Luxembourg and Aid flow (current US$) of Finland?
Your answer should be compact. 1.05e+07. In the year 2007, what is the difference between the Aid flow (current US$) in Australia and Aid flow (current US$) in Finland?
Keep it short and to the point. -3.24e+06. In the year 2008, what is the difference between the Aid flow (current US$) of Greece and Aid flow (current US$) of Luxembourg?
Your answer should be compact. -7.05e+06. In the year 2008, what is the difference between the Aid flow (current US$) in Greece and Aid flow (current US$) in Australia?
Keep it short and to the point. 6.96e+06. In the year 2008, what is the difference between the Aid flow (current US$) in Greece and Aid flow (current US$) in Finland?
Keep it short and to the point. 2.00e+06. In the year 2008, what is the difference between the Aid flow (current US$) in Luxembourg and Aid flow (current US$) in Australia?
Keep it short and to the point. 1.40e+07. In the year 2008, what is the difference between the Aid flow (current US$) of Luxembourg and Aid flow (current US$) of Finland?
Give a very brief answer. 9.05e+06. In the year 2008, what is the difference between the Aid flow (current US$) of Australia and Aid flow (current US$) of Finland?
Your answer should be compact. -4.96e+06. In the year 2009, what is the difference between the Aid flow (current US$) in Greece and Aid flow (current US$) in Luxembourg?
Your response must be concise. -1.97e+07. In the year 2009, what is the difference between the Aid flow (current US$) of Greece and Aid flow (current US$) of Australia?
Ensure brevity in your answer.  3.04e+06. In the year 2009, what is the difference between the Aid flow (current US$) in Greece and Aid flow (current US$) in Finland?
Make the answer very short. -3.27e+06. In the year 2009, what is the difference between the Aid flow (current US$) of Luxembourg and Aid flow (current US$) of Australia?
Provide a succinct answer. 2.27e+07. In the year 2009, what is the difference between the Aid flow (current US$) of Luxembourg and Aid flow (current US$) of Finland?
Make the answer very short. 1.64e+07. In the year 2009, what is the difference between the Aid flow (current US$) of Australia and Aid flow (current US$) of Finland?
Keep it short and to the point. -6.31e+06. What is the ratio of the Aid flow (current US$) of Greece in 2002 to that in 2003?
Give a very brief answer. 0.37. What is the ratio of the Aid flow (current US$) in Luxembourg in 2002 to that in 2003?
Give a very brief answer. 1.36. What is the ratio of the Aid flow (current US$) in Finland in 2002 to that in 2003?
Provide a short and direct response. 0.55. What is the ratio of the Aid flow (current US$) of Greece in 2002 to that in 2004?
Offer a terse response. 0.25. What is the ratio of the Aid flow (current US$) in Luxembourg in 2002 to that in 2004?
Make the answer very short. 0.9. What is the ratio of the Aid flow (current US$) of Australia in 2002 to that in 2004?
Your answer should be very brief. 0.29. What is the ratio of the Aid flow (current US$) of Finland in 2002 to that in 2004?
Keep it short and to the point. 8.36. What is the ratio of the Aid flow (current US$) of Greece in 2002 to that in 2005?
Your answer should be compact. 0.09. What is the ratio of the Aid flow (current US$) in Luxembourg in 2002 to that in 2005?
Your response must be concise. 0.56. What is the ratio of the Aid flow (current US$) of Finland in 2002 to that in 2005?
Provide a succinct answer. 1.05. What is the ratio of the Aid flow (current US$) of Greece in 2002 to that in 2006?
Offer a very short reply. 0.11. What is the ratio of the Aid flow (current US$) of Luxembourg in 2002 to that in 2006?
Offer a very short reply. 0.68. What is the ratio of the Aid flow (current US$) in Australia in 2002 to that in 2006?
Give a very brief answer. 0.22. What is the ratio of the Aid flow (current US$) of Finland in 2002 to that in 2006?
Your answer should be very brief. 1.05. What is the ratio of the Aid flow (current US$) of Greece in 2002 to that in 2007?
Provide a short and direct response. 0.04. What is the ratio of the Aid flow (current US$) of Luxembourg in 2002 to that in 2007?
Ensure brevity in your answer.  0.77. What is the ratio of the Aid flow (current US$) of Australia in 2002 to that in 2007?
Your answer should be compact. 0.11. What is the ratio of the Aid flow (current US$) in Finland in 2002 to that in 2007?
Ensure brevity in your answer.  0.34. What is the ratio of the Aid flow (current US$) of Greece in 2002 to that in 2008?
Provide a short and direct response. 0.02. What is the ratio of the Aid flow (current US$) in Luxembourg in 2002 to that in 2008?
Your response must be concise. 0.75. What is the ratio of the Aid flow (current US$) of Australia in 2002 to that in 2008?
Your response must be concise. 0.09. What is the ratio of the Aid flow (current US$) in Finland in 2002 to that in 2008?
Make the answer very short. 0.23. What is the ratio of the Aid flow (current US$) of Greece in 2002 to that in 2009?
Keep it short and to the point. 0.05. What is the ratio of the Aid flow (current US$) in Luxembourg in 2002 to that in 2009?
Make the answer very short. 0.46. What is the ratio of the Aid flow (current US$) of Australia in 2002 to that in 2009?
Make the answer very short. 0.05. What is the ratio of the Aid flow (current US$) of Finland in 2002 to that in 2009?
Your answer should be compact. 0.18. What is the ratio of the Aid flow (current US$) in Greece in 2003 to that in 2004?
Offer a terse response. 0.69. What is the ratio of the Aid flow (current US$) in Luxembourg in 2003 to that in 2004?
Keep it short and to the point. 0.66. What is the ratio of the Aid flow (current US$) of Australia in 2003 to that in 2004?
Provide a succinct answer. 0.43. What is the ratio of the Aid flow (current US$) of Finland in 2003 to that in 2004?
Provide a succinct answer. 15.21. What is the ratio of the Aid flow (current US$) of Greece in 2003 to that in 2005?
Keep it short and to the point. 0.25. What is the ratio of the Aid flow (current US$) of Luxembourg in 2003 to that in 2005?
Your response must be concise. 0.41. What is the ratio of the Aid flow (current US$) of Australia in 2003 to that in 2005?
Provide a succinct answer. 0.38. What is the ratio of the Aid flow (current US$) in Finland in 2003 to that in 2005?
Offer a terse response. 1.92. What is the ratio of the Aid flow (current US$) in Greece in 2003 to that in 2006?
Your answer should be very brief. 0.31. What is the ratio of the Aid flow (current US$) in Luxembourg in 2003 to that in 2006?
Your answer should be very brief. 0.5. What is the ratio of the Aid flow (current US$) of Finland in 2003 to that in 2006?
Offer a terse response. 1.92. What is the ratio of the Aid flow (current US$) of Greece in 2003 to that in 2007?
Your answer should be compact. 0.1. What is the ratio of the Aid flow (current US$) in Luxembourg in 2003 to that in 2007?
Your answer should be compact. 0.57. What is the ratio of the Aid flow (current US$) of Finland in 2003 to that in 2007?
Your answer should be compact. 0.62. What is the ratio of the Aid flow (current US$) of Greece in 2003 to that in 2008?
Provide a succinct answer. 0.06. What is the ratio of the Aid flow (current US$) in Luxembourg in 2003 to that in 2008?
Ensure brevity in your answer.  0.56. What is the ratio of the Aid flow (current US$) of Australia in 2003 to that in 2008?
Your response must be concise. 0.13. What is the ratio of the Aid flow (current US$) in Finland in 2003 to that in 2008?
Provide a succinct answer. 0.41. What is the ratio of the Aid flow (current US$) in Greece in 2003 to that in 2009?
Make the answer very short. 0.13. What is the ratio of the Aid flow (current US$) in Luxembourg in 2003 to that in 2009?
Give a very brief answer. 0.34. What is the ratio of the Aid flow (current US$) in Australia in 2003 to that in 2009?
Make the answer very short. 0.08. What is the ratio of the Aid flow (current US$) of Finland in 2003 to that in 2009?
Your response must be concise. 0.32. What is the ratio of the Aid flow (current US$) of Greece in 2004 to that in 2005?
Keep it short and to the point. 0.37. What is the ratio of the Aid flow (current US$) in Luxembourg in 2004 to that in 2005?
Your response must be concise. 0.62. What is the ratio of the Aid flow (current US$) in Finland in 2004 to that in 2005?
Offer a very short reply. 0.13. What is the ratio of the Aid flow (current US$) of Greece in 2004 to that in 2006?
Your response must be concise. 0.45. What is the ratio of the Aid flow (current US$) of Luxembourg in 2004 to that in 2006?
Your response must be concise. 0.75. What is the ratio of the Aid flow (current US$) in Australia in 2004 to that in 2006?
Make the answer very short. 0.78. What is the ratio of the Aid flow (current US$) of Finland in 2004 to that in 2006?
Your response must be concise. 0.13. What is the ratio of the Aid flow (current US$) of Greece in 2004 to that in 2007?
Provide a succinct answer. 0.15. What is the ratio of the Aid flow (current US$) of Luxembourg in 2004 to that in 2007?
Offer a terse response. 0.86. What is the ratio of the Aid flow (current US$) of Australia in 2004 to that in 2007?
Provide a short and direct response. 0.39. What is the ratio of the Aid flow (current US$) in Finland in 2004 to that in 2007?
Provide a succinct answer. 0.04. What is the ratio of the Aid flow (current US$) of Greece in 2004 to that in 2008?
Your answer should be compact. 0.09. What is the ratio of the Aid flow (current US$) of Luxembourg in 2004 to that in 2008?
Make the answer very short. 0.84. What is the ratio of the Aid flow (current US$) of Australia in 2004 to that in 2008?
Keep it short and to the point. 0.3. What is the ratio of the Aid flow (current US$) of Finland in 2004 to that in 2008?
Offer a terse response. 0.03. What is the ratio of the Aid flow (current US$) in Greece in 2004 to that in 2009?
Offer a very short reply. 0.2. What is the ratio of the Aid flow (current US$) in Luxembourg in 2004 to that in 2009?
Ensure brevity in your answer.  0.52. What is the ratio of the Aid flow (current US$) in Australia in 2004 to that in 2009?
Offer a terse response. 0.19. What is the ratio of the Aid flow (current US$) in Finland in 2004 to that in 2009?
Your response must be concise. 0.02. What is the ratio of the Aid flow (current US$) of Greece in 2005 to that in 2006?
Offer a very short reply. 1.21. What is the ratio of the Aid flow (current US$) of Luxembourg in 2005 to that in 2006?
Your answer should be very brief. 1.22. What is the ratio of the Aid flow (current US$) in Australia in 2005 to that in 2006?
Offer a very short reply. 0.89. What is the ratio of the Aid flow (current US$) in Greece in 2005 to that in 2007?
Your response must be concise. 0.4. What is the ratio of the Aid flow (current US$) in Luxembourg in 2005 to that in 2007?
Ensure brevity in your answer.  1.39. What is the ratio of the Aid flow (current US$) of Australia in 2005 to that in 2007?
Provide a succinct answer. 0.44. What is the ratio of the Aid flow (current US$) of Finland in 2005 to that in 2007?
Offer a terse response. 0.32. What is the ratio of the Aid flow (current US$) of Greece in 2005 to that in 2008?
Your answer should be compact. 0.25. What is the ratio of the Aid flow (current US$) in Luxembourg in 2005 to that in 2008?
Give a very brief answer. 1.36. What is the ratio of the Aid flow (current US$) in Australia in 2005 to that in 2008?
Offer a very short reply. 0.35. What is the ratio of the Aid flow (current US$) of Finland in 2005 to that in 2008?
Give a very brief answer. 0.21. What is the ratio of the Aid flow (current US$) of Greece in 2005 to that in 2009?
Offer a very short reply. 0.53. What is the ratio of the Aid flow (current US$) in Luxembourg in 2005 to that in 2009?
Give a very brief answer. 0.84. What is the ratio of the Aid flow (current US$) in Australia in 2005 to that in 2009?
Your answer should be very brief. 0.22. What is the ratio of the Aid flow (current US$) in Finland in 2005 to that in 2009?
Your response must be concise. 0.17. What is the ratio of the Aid flow (current US$) of Greece in 2006 to that in 2007?
Your answer should be compact. 0.33. What is the ratio of the Aid flow (current US$) in Luxembourg in 2006 to that in 2007?
Offer a terse response. 1.14. What is the ratio of the Aid flow (current US$) in Australia in 2006 to that in 2007?
Your answer should be very brief. 0.5. What is the ratio of the Aid flow (current US$) of Finland in 2006 to that in 2007?
Make the answer very short. 0.32. What is the ratio of the Aid flow (current US$) of Greece in 2006 to that in 2008?
Make the answer very short. 0.21. What is the ratio of the Aid flow (current US$) of Luxembourg in 2006 to that in 2008?
Your answer should be compact. 1.11. What is the ratio of the Aid flow (current US$) in Australia in 2006 to that in 2008?
Ensure brevity in your answer.  0.39. What is the ratio of the Aid flow (current US$) in Finland in 2006 to that in 2008?
Offer a very short reply. 0.21. What is the ratio of the Aid flow (current US$) in Greece in 2006 to that in 2009?
Provide a short and direct response. 0.44. What is the ratio of the Aid flow (current US$) in Luxembourg in 2006 to that in 2009?
Ensure brevity in your answer.  0.69. What is the ratio of the Aid flow (current US$) in Australia in 2006 to that in 2009?
Make the answer very short. 0.24. What is the ratio of the Aid flow (current US$) in Finland in 2006 to that in 2009?
Provide a succinct answer. 0.17. What is the ratio of the Aid flow (current US$) of Greece in 2007 to that in 2008?
Your response must be concise. 0.63. What is the ratio of the Aid flow (current US$) of Luxembourg in 2007 to that in 2008?
Your answer should be very brief. 0.98. What is the ratio of the Aid flow (current US$) of Australia in 2007 to that in 2008?
Provide a succinct answer. 0.78. What is the ratio of the Aid flow (current US$) of Finland in 2007 to that in 2008?
Make the answer very short. 0.66. What is the ratio of the Aid flow (current US$) of Greece in 2007 to that in 2009?
Keep it short and to the point. 1.32. What is the ratio of the Aid flow (current US$) of Luxembourg in 2007 to that in 2009?
Provide a succinct answer. 0.6. What is the ratio of the Aid flow (current US$) of Australia in 2007 to that in 2009?
Give a very brief answer. 0.49. What is the ratio of the Aid flow (current US$) of Finland in 2007 to that in 2009?
Make the answer very short. 0.51. What is the ratio of the Aid flow (current US$) of Greece in 2008 to that in 2009?
Offer a very short reply. 2.11. What is the ratio of the Aid flow (current US$) of Luxembourg in 2008 to that in 2009?
Give a very brief answer. 0.62. What is the ratio of the Aid flow (current US$) in Australia in 2008 to that in 2009?
Provide a short and direct response. 0.62. What is the ratio of the Aid flow (current US$) in Finland in 2008 to that in 2009?
Give a very brief answer. 0.78. What is the difference between the highest and the second highest Aid flow (current US$) in Greece?
Provide a succinct answer. 2.69e+06. What is the difference between the highest and the second highest Aid flow (current US$) in Luxembourg?
Keep it short and to the point. 3.78e+06. What is the difference between the highest and the second highest Aid flow (current US$) in Australia?
Ensure brevity in your answer.  1.40e+05. What is the difference between the highest and the second highest Aid flow (current US$) of Finland?
Offer a very short reply. 1.49e+06. What is the difference between the highest and the lowest Aid flow (current US$) of Greece?
Your answer should be very brief. 7.02e+06. What is the difference between the highest and the lowest Aid flow (current US$) in Luxembourg?
Ensure brevity in your answer.  1.52e+07. What is the difference between the highest and the lowest Aid flow (current US$) of Australia?
Keep it short and to the point. 3.50e+05. What is the difference between the highest and the lowest Aid flow (current US$) of Finland?
Make the answer very short. 6.54e+06. 